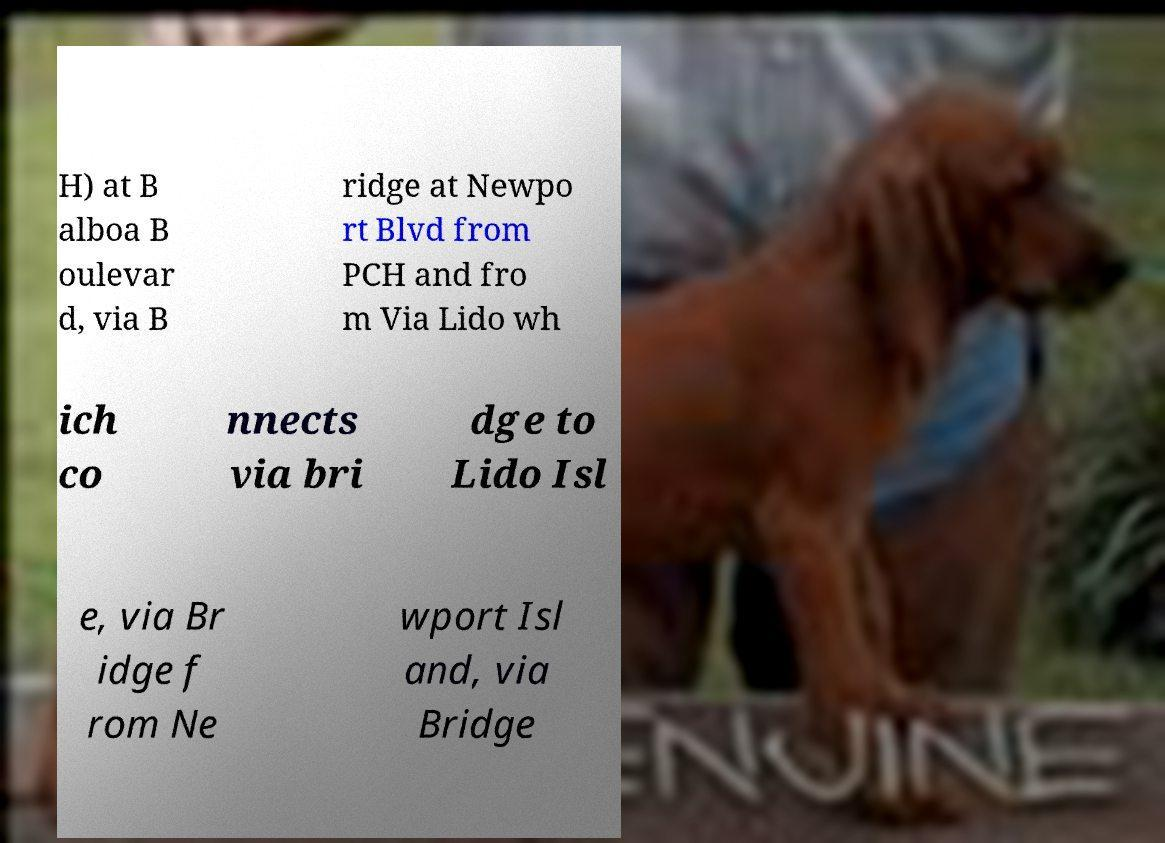Please read and relay the text visible in this image. What does it say? H) at B alboa B oulevar d, via B ridge at Newpo rt Blvd from PCH and fro m Via Lido wh ich co nnects via bri dge to Lido Isl e, via Br idge f rom Ne wport Isl and, via Bridge 